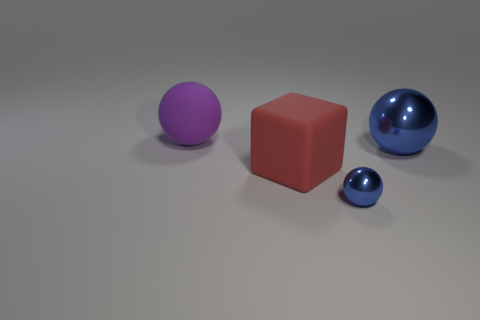Add 1 cubes. How many objects exist? 5 Subtract all spheres. How many objects are left? 1 Add 4 large blue metal spheres. How many large blue metal spheres are left? 5 Add 4 large yellow metallic cylinders. How many large yellow metallic cylinders exist? 4 Subtract 0 yellow cubes. How many objects are left? 4 Subtract all large brown metallic balls. Subtract all large purple objects. How many objects are left? 3 